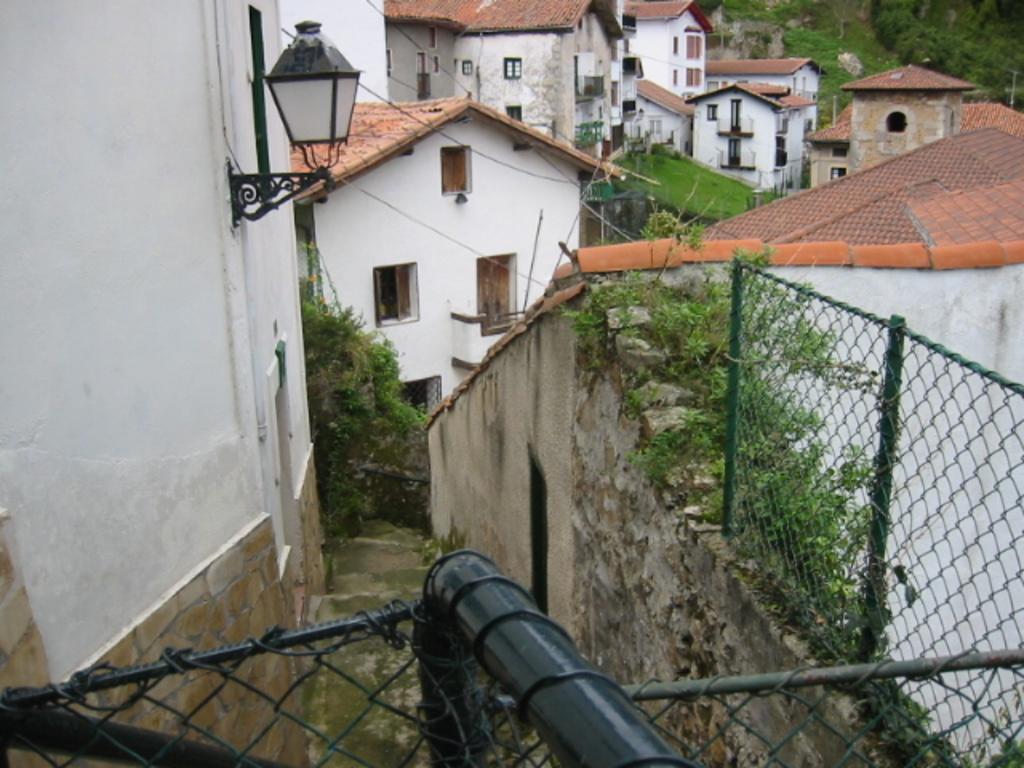Could you give a brief overview of what you see in this image? In the center of the image we can see buildings, windows, roofs, grass, light. At the top of the image we can see trees, poles. At the bottom of the image we can see wall, mesh, stairs and some plants. 